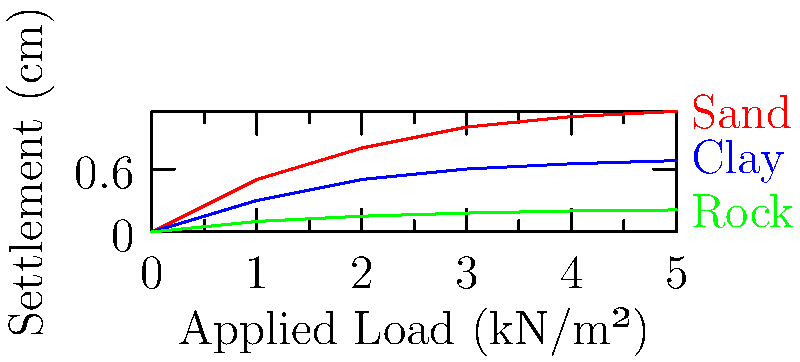Given the settlement curves for different soil types under increasing load, which soil type exhibits the greatest settlement at a load of 3 kN/m²? Explain the biological significance of soil settlement patterns in the context of plant root development and adaptation. To answer this question, we need to analyze the settlement curves for each soil type at a load of 3 kN/m²:

1. Identify the settlement values at 3 kN/m²:
   Sand: ~1.0 cm
   Clay: ~0.6 cm
   Rock: ~0.18 cm

2. Compare the settlement values:
   Sand > Clay > Rock

3. Biological significance in plant root development and adaptation:

   a) Sand settlement:
      - Highest settlement indicates loose structure and large pore spaces.
      - Allows for easy root penetration and growth.
      - Facilitates water drainage but may lead to nutrient leaching.
      - Plants may develop extensive root systems to access water and nutrients.

   b) Clay settlement:
      - Moderate settlement suggests smaller pore spaces and higher water retention.
      - Can hold more nutrients but may have poor aeration.
      - Plants may develop specialized root structures for oxygen access.

   c) Rock settlement:
      - Lowest settlement indicates high density and limited pore spaces.
      - Restricts root growth and water availability.
      - Plants may evolve specialized root systems to penetrate cracks or develop shallow, spreading roots.

4. Adaptive strategies:
   - Plants in sandy soils may develop deep taproots or extensive fibrous root systems.
   - Plants in clay soils may form aerenchyma tissue for improved oxygen transport.
   - Plants in rocky soils may exhibit stress-tolerant traits or develop symbiotic relationships with mycorrhizal fungi.

Understanding soil settlement patterns is crucial for predicting plant distribution, adaptation, and ecosystem development in various soil conditions.
Answer: Sand exhibits the greatest settlement (1.0 cm) at 3 kN/m². 